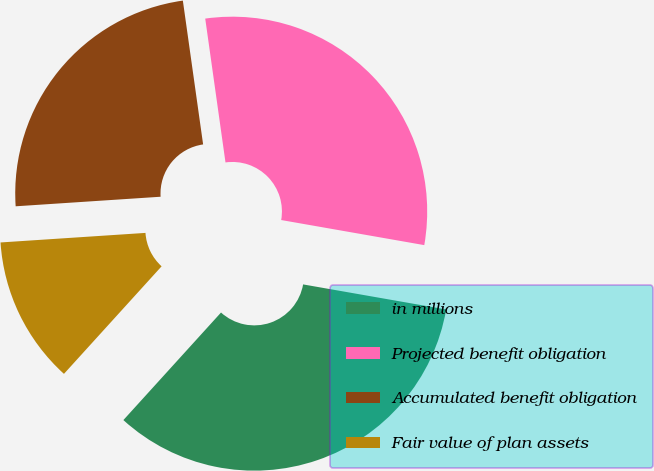<chart> <loc_0><loc_0><loc_500><loc_500><pie_chart><fcel>in millions<fcel>Projected benefit obligation<fcel>Accumulated benefit obligation<fcel>Fair value of plan assets<nl><fcel>33.97%<fcel>29.99%<fcel>23.82%<fcel>12.22%<nl></chart> 